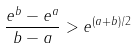<formula> <loc_0><loc_0><loc_500><loc_500>\frac { e ^ { b } - e ^ { a } } { b - a } > e ^ { ( a + b ) / 2 }</formula> 